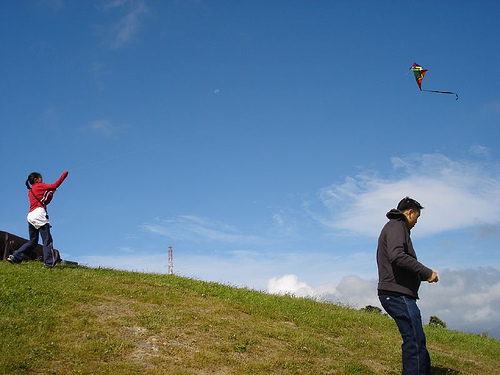<image>Does the kite have a blue tail? I don't know if the kite has a blue tail. It can be both yes or no. Does the kite have a blue tail? I don't know if the kite has a blue tail. It can be both yes and no. 